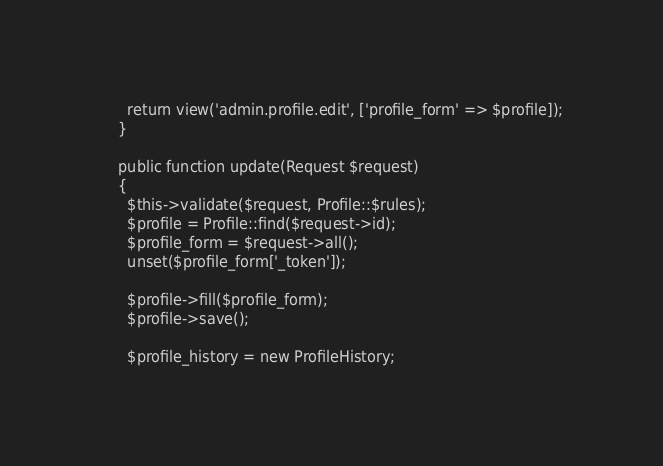<code> <loc_0><loc_0><loc_500><loc_500><_PHP_>
      return view('admin.profile.edit', ['profile_form' => $profile]);
    }

    public function update(Request $request)
    {
      $this->validate($request, Profile::$rules);
      $profile = Profile::find($request->id);
      $profile_form = $request->all();
      unset($profile_form['_token']);

      $profile->fill($profile_form);
      $profile->save();

      $profile_history = new ProfileHistory;</code> 